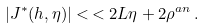<formula> <loc_0><loc_0><loc_500><loc_500>| J ^ { * } ( h , \eta ) | < \, < 2 L \eta + 2 \rho ^ { a n } \, .</formula> 